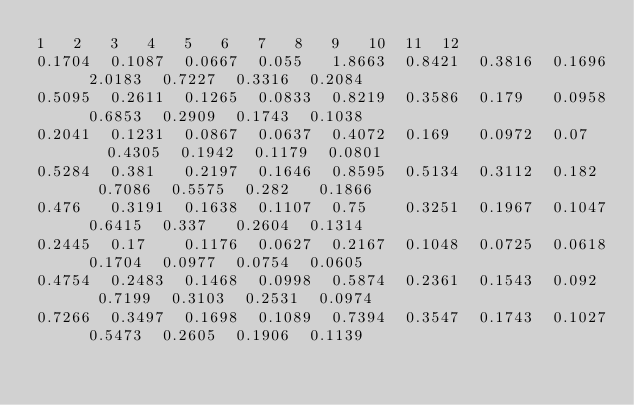<code> <loc_0><loc_0><loc_500><loc_500><_SQL_>1	2	3	4	5	6	7	8	9	10	11	12
0.1704	0.1087	0.0667	0.055	1.8663	0.8421	0.3816	0.1696	2.0183	0.7227	0.3316	0.2084
0.5095	0.2611	0.1265	0.0833	0.8219	0.3586	0.179	0.0958	0.6853	0.2909	0.1743	0.1038
0.2041	0.1231	0.0867	0.0637	0.4072	0.169	0.0972	0.07	0.4305	0.1942	0.1179	0.0801
0.5284	0.381	0.2197	0.1646	0.8595	0.5134	0.3112	0.182	0.7086	0.5575	0.282	0.1866
0.476	0.3191	0.1638	0.1107	0.75	0.3251	0.1967	0.1047	0.6415	0.337	0.2604	0.1314
0.2445	0.17	0.1176	0.0627	0.2167	0.1048	0.0725	0.0618	0.1704	0.0977	0.0754	0.0605
0.4754	0.2483	0.1468	0.0998	0.5874	0.2361	0.1543	0.092	0.7199	0.3103	0.2531	0.0974
0.7266	0.3497	0.1698	0.1089	0.7394	0.3547	0.1743	0.1027	0.5473	0.2605	0.1906	0.1139
</code> 